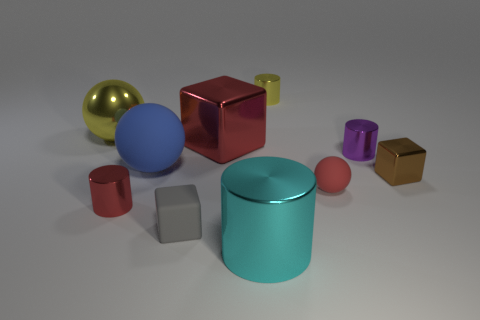Can you describe the lighting in this scene? The lighting in the scene is soft and diffused, giving the objects gentle shadows and subtle reflections. It seems to come from a non-directional source, providing even illumination without harsh highlights or deep shadows. 